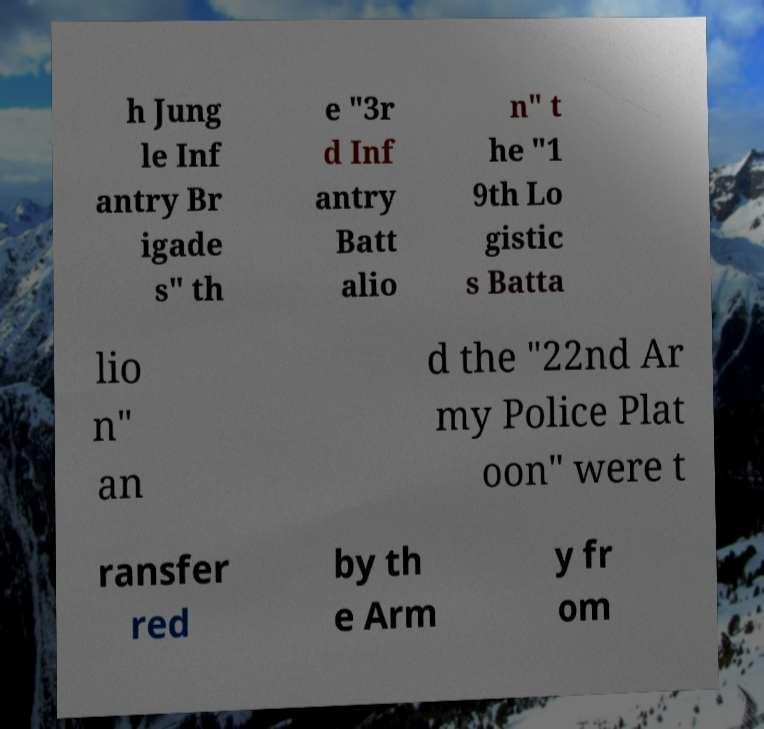Can you read and provide the text displayed in the image?This photo seems to have some interesting text. Can you extract and type it out for me? h Jung le Inf antry Br igade s" th e "3r d Inf antry Batt alio n" t he "1 9th Lo gistic s Batta lio n" an d the "22nd Ar my Police Plat oon" were t ransfer red by th e Arm y fr om 